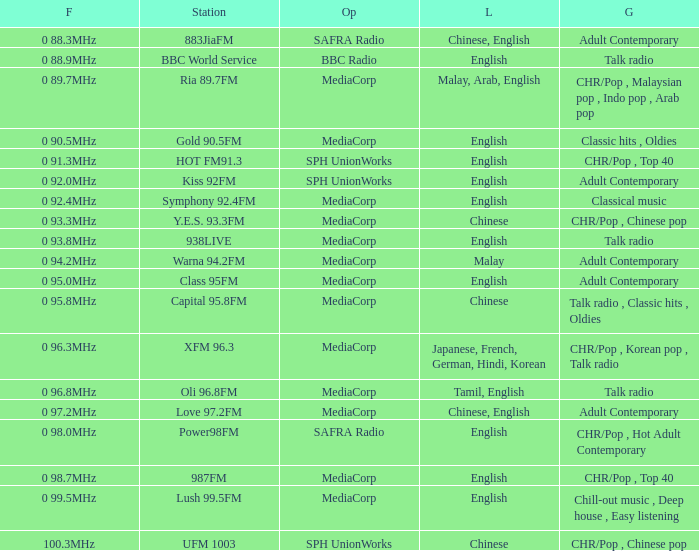Which talk radio genre station is managed by bbc radio? BBC World Service. 